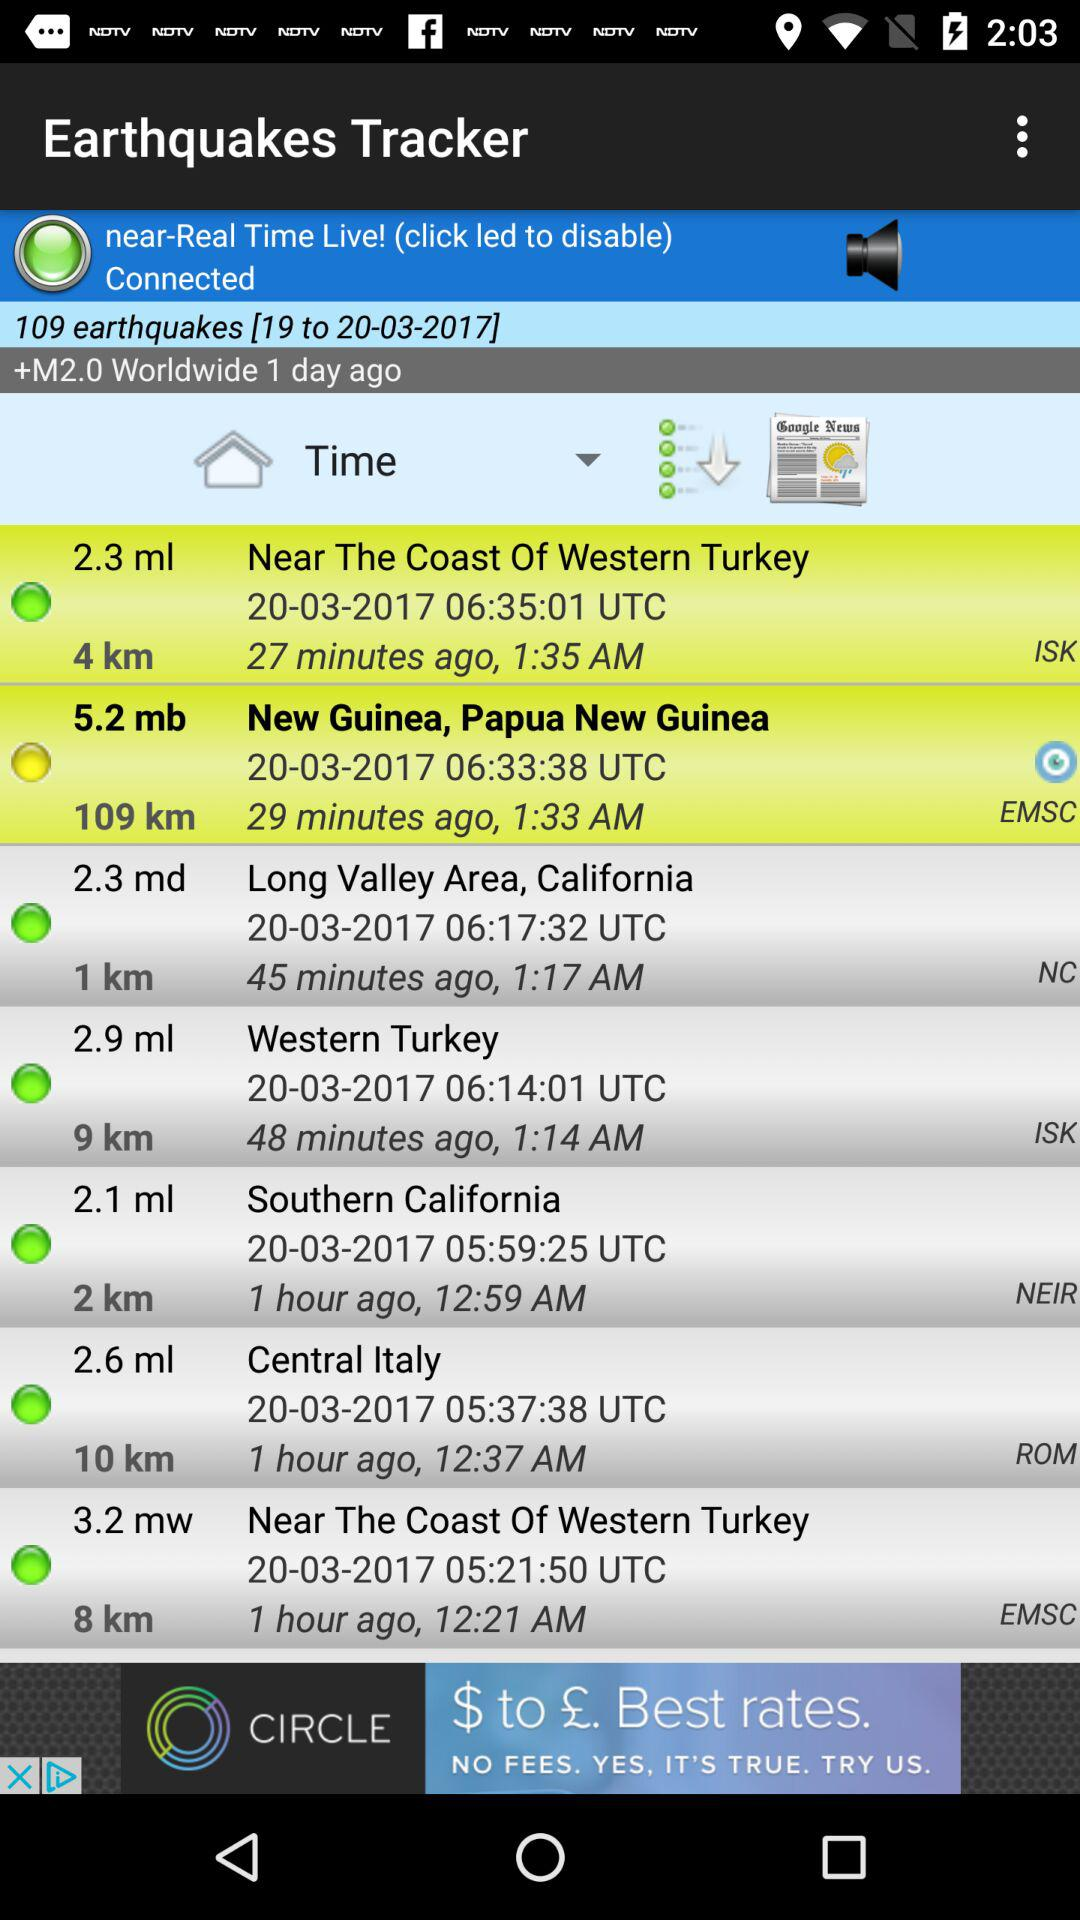How long ago did the earthquake in New Guinea occur? The earthquake occurred 29 minutes ago. 